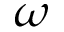<formula> <loc_0><loc_0><loc_500><loc_500>\omega</formula> 